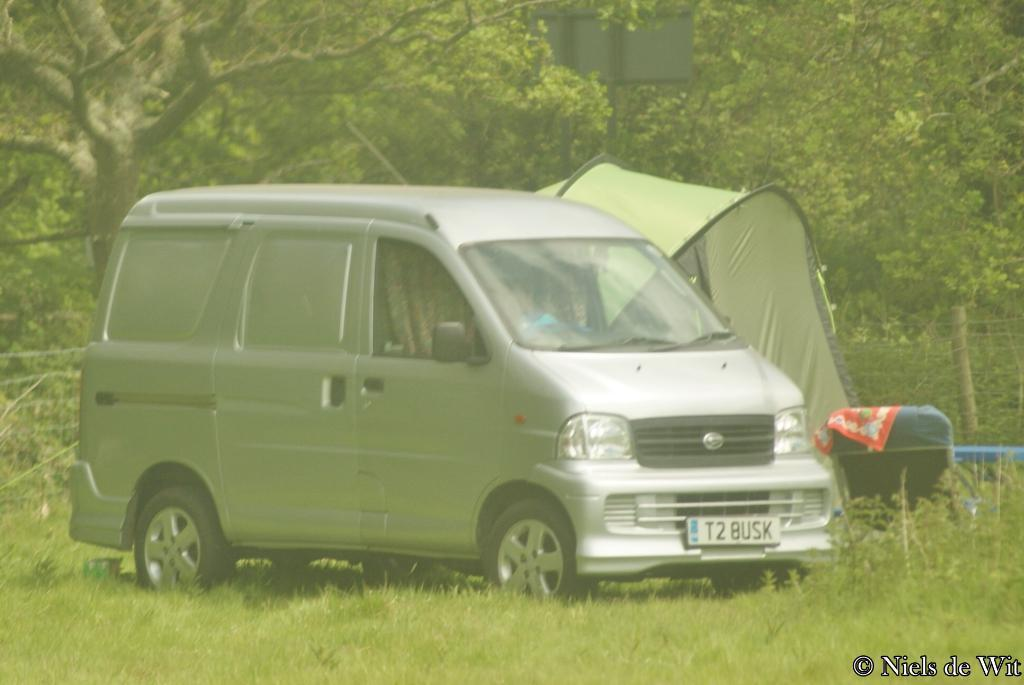<image>
Relay a brief, clear account of the picture shown. A silver van says T2 BUSK on the front license plate. 